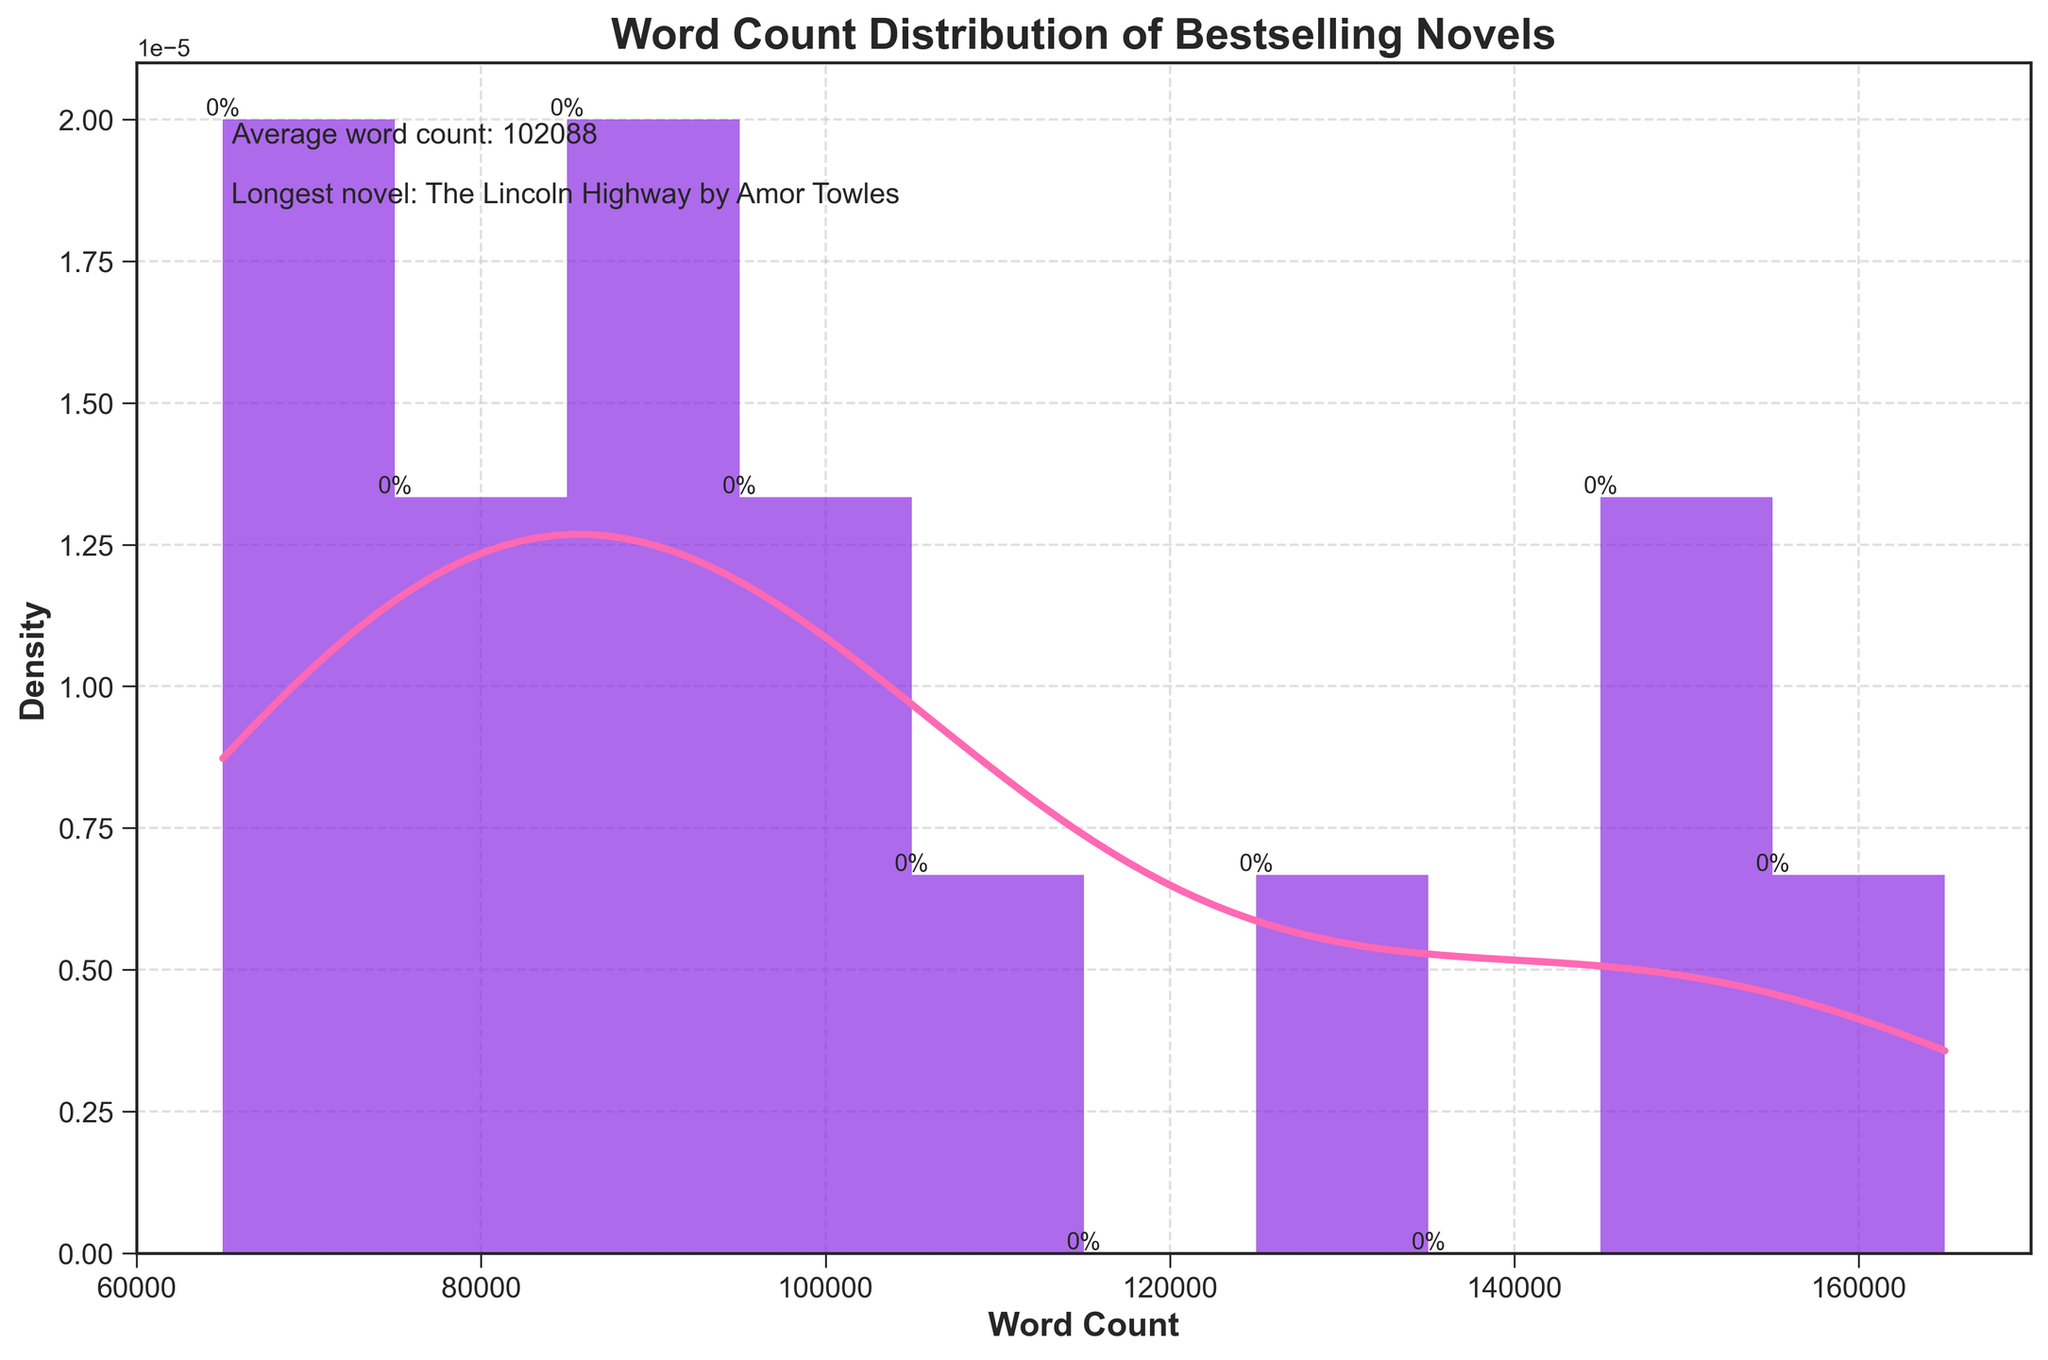What is the title of the figure? The title is usually written at the top of the figure in bold text. In this case, the title reads "Word Count Distribution of Bestselling Novels".
Answer: Word Count Distribution of Bestselling Novels What color is used for the density curve (KDE)? The density curve (KDE) is drawn in a distinctive color to distinguish it from the histogram bars. Here, the KDE is in pink.
Answer: Pink What is the average word count of the novels? The average word count is often indicated directly in a figure annotation. The figure text mentions "Average word count: 98,667" which gives a clear answer.
Answer: 98,667 Which novel has the longest word count? The novel with the longest word count is annotated in the figure. The text annotation states "Longest novel: The Lincoln Highway by Amor Towles".
Answer: The Lincoln Highway by Amor Towles How many bars are in the histogram? The number of bars in a histogram corresponds to the "bins" used for distribution. By counting the bars, we see there are 10 bars in the histogram.
Answer: 10 What is the range of word counts for the novels? The X-axis of the histogram shows the range of word counts. The minimum value is around 65,000 and the maximum is approximately 165,000.
Answer: 65,000 to 165,000 What can you infer from the density of novels with word counts around 100,000? The density curve (KDE) shows the density of data points. Around the word count of 100,000, the curve peaks, indicating a high concentration of novels near this word count.
Answer: High concentration Is there a skew in the word count distribution? If yes, in which direction? A skew in distribution can be observed by looking at the tail of the density curve. Here, the histogram and density curve show a longer tail to the right, indicating a right (positive) skew.
Answer: Right skew Compare the density of novels with word counts around 70,000 to those around 150,000. By analyzing the KDE, the density around 70,000 is higher than around 150,000. This indicates that novels with word counts near 70,000 are more common than those near 150,000.
Answer: Higher near 70,000 